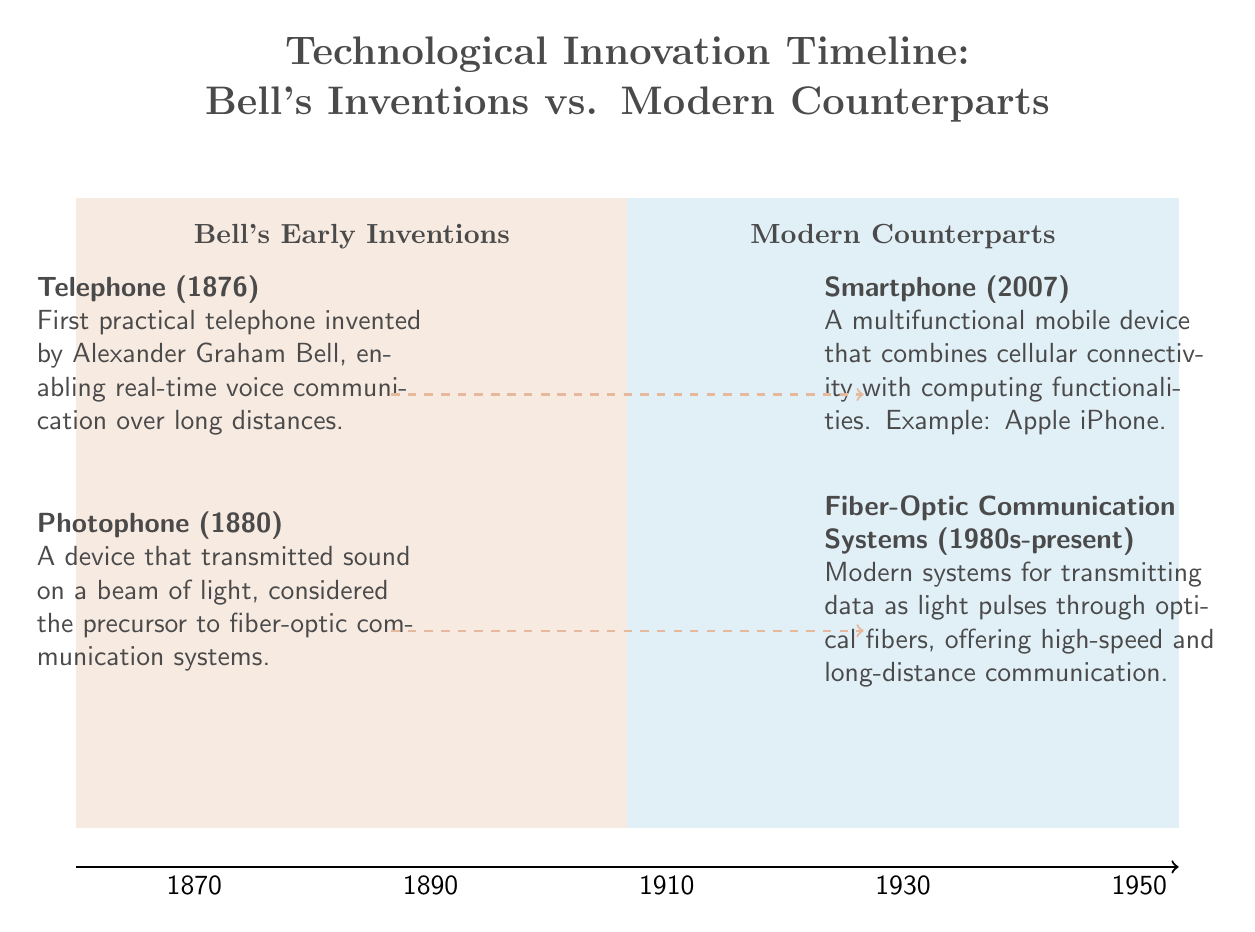What year was the telephone invented? The telephone was invented in 1876 as indicated in the quadrant labeled "Bell's Early Inventions."
Answer: 1876 What device did Bell invent in 1880? The device invented by Bell in 1880 is the Photophone, as noted in the same quadrant.
Answer: Photophone Which modern counterpart was introduced in 2007? The modern counterpart introduced in 2007 is the Smartphone, mentioned in the quadrant labeled "Modern Counterparts."
Answer: Smartphone What is the main communication technology that the Photophone is considered a precursor to? The Photophone is considered the precursor to fiber-optic communication systems, as it transmitted sound on a beam of light.
Answer: Fiber-optic communication systems How many inventions are listed under Bell's Early Inventions? There are two inventions listed under Bell's Early Inventions: the Telephone and the Photophone.
Answer: 2 What type of communication method do modern fiber-optic systems use? Modern fiber-optic communication systems use light pulses for transmitting data, as described in the quadrant.
Answer: Light pulses What is the time period indicated for modern fiber-optic communication systems? The time period indicated for modern fiber-optic communication systems is 1980s-present, showcasing its ongoing relevance.
Answer: 1980s-present Which quadrant contains Bell's inventions? The quadrant containing Bell's inventions is labeled "Bell's Early Inventions."
Answer: Bell's Early Inventions How are the telephone and the smartphone related in terms of technological progression? The telephone is the first practical device invented by Bell, and the smartphone is a modern counterpart that combines several functionalities, showcasing the evolution of communication technology.
Answer: Evolution of communication technology 